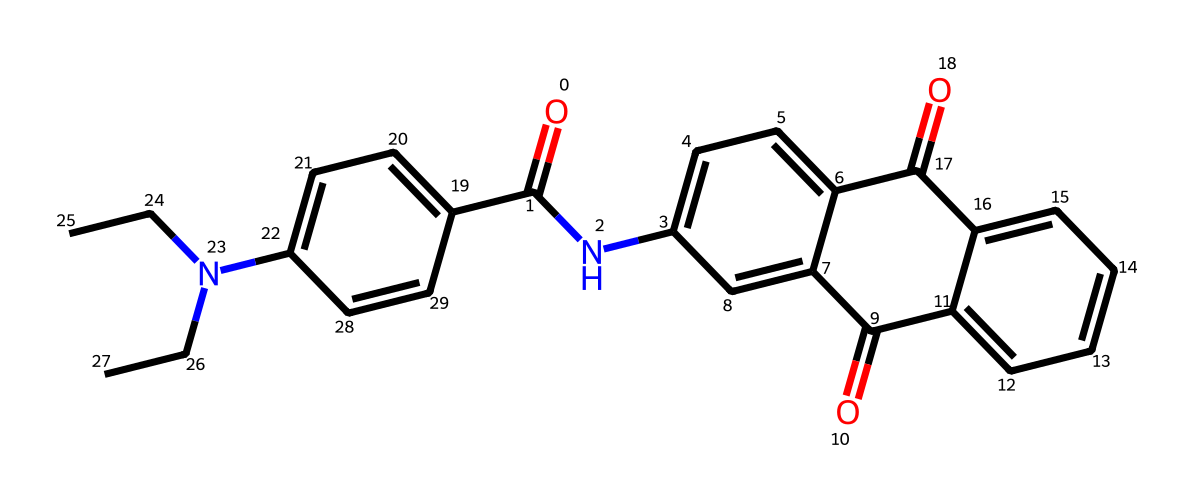What is the primary functional group present in this chemical? The primary functional group is an amide, indicated by the carbonyl group (O=C) directly attached to a nitrogen (Nc1).
Answer: amide How many aromatic rings are present in this molecule? The molecule contains two aromatic rings, which can be identified from the cyclic structures containing alternating double bonds and consistent with aromaticity (c1 and c2 in the SMILES representation).
Answer: two What type of chemical is this molecule primarily associated with? Given its structure and properties, this molecule is primarily associated with detergents due to its optical brightening capabilities, typically utilized in laundry applications.
Answer: detergents What is the total number of nitrogen atoms in this compound? There are two nitrogen atoms present which can be counted from the two occurrences of 'N' in the SMILES representation: Nc1 and N(CC)CC.
Answer: two Which elements are primarily responsible for the molecule's stability? The stability of the molecule primarily comes from the carbon and nitrogen bonds that create a robust framework, alongside the involvement of aromatic stability due to the presence of conjugated pi systems.
Answer: carbon and nitrogen 